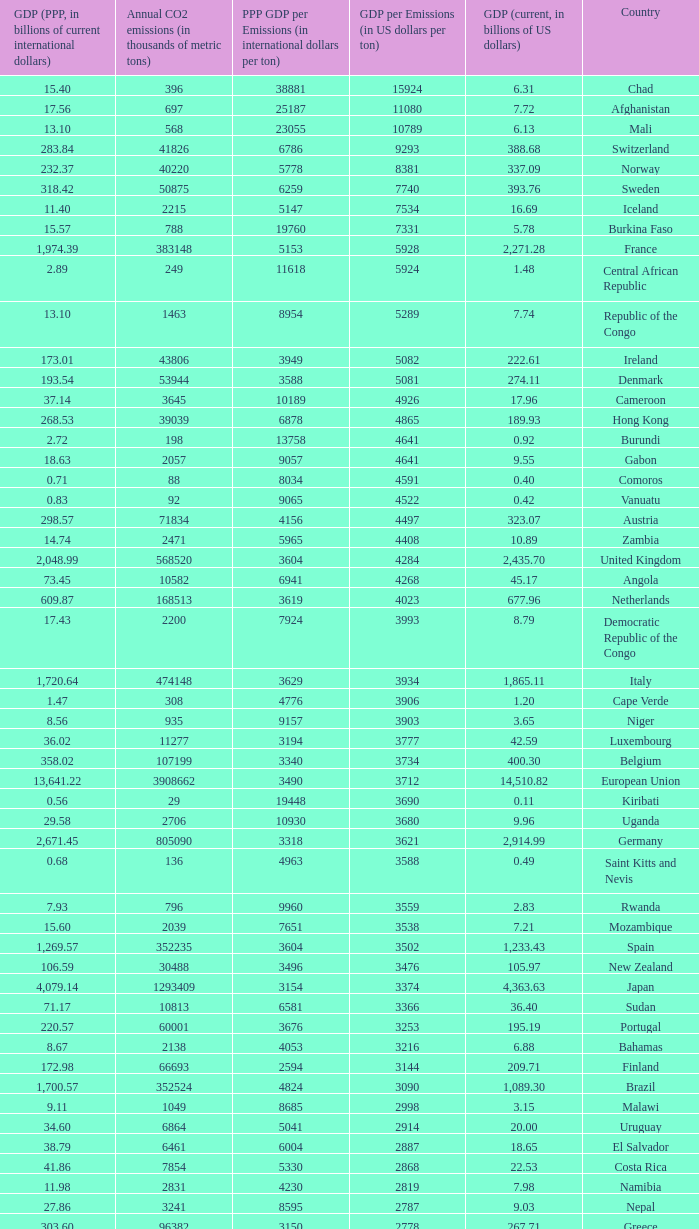When the gdp (current, in billions of us dollars) is 162.50, what is the gdp? 2562.0. 